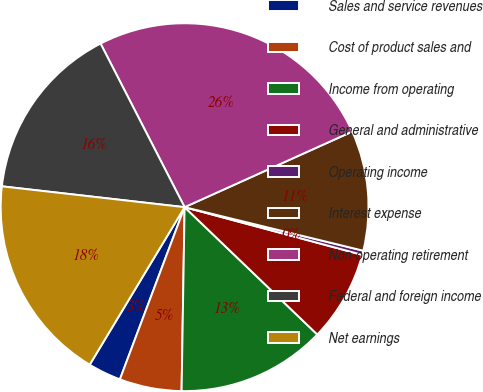Convert chart. <chart><loc_0><loc_0><loc_500><loc_500><pie_chart><fcel>Sales and service revenues<fcel>Cost of product sales and<fcel>Income from operating<fcel>General and administrative<fcel>Operating income<fcel>Interest expense<fcel>Non-operating retirement<fcel>Federal and foreign income<fcel>Net earnings<nl><fcel>2.91%<fcel>5.46%<fcel>13.09%<fcel>8.0%<fcel>0.37%<fcel>10.55%<fcel>25.81%<fcel>15.64%<fcel>18.18%<nl></chart> 